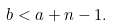<formula> <loc_0><loc_0><loc_500><loc_500>b < a + n - 1 .</formula> 